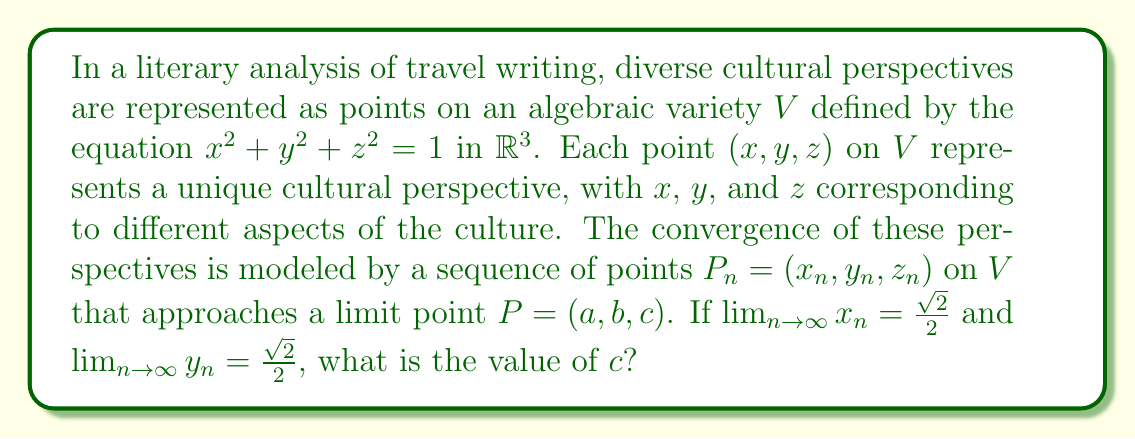Could you help me with this problem? Let's approach this step-by-step:

1) The algebraic variety $V$ is defined by the equation $x^2 + y^2 + z^2 = 1$. This is the equation of a unit sphere in $\mathbb{R}^3$.

2) We're told that the sequence of points $P_n = (x_n, y_n, z_n)$ converges to a limit point $P = (a, b, c)$ on $V$.

3) We're given that:
   $\lim_{n \to \infty} x_n = a = \frac{\sqrt{2}}{2}$
   $\lim_{n \to \infty} y_n = b = \frac{\sqrt{2}}{2}$

4) Since the limit point $P = (a, b, c)$ is on $V$, it must satisfy the equation of the sphere:

   $a^2 + b^2 + c^2 = 1$

5) Substituting the known values:

   $(\frac{\sqrt{2}}{2})^2 + (\frac{\sqrt{2}}{2})^2 + c^2 = 1$

6) Simplify:
   $\frac{2}{4} + \frac{2}{4} + c^2 = 1$
   $\frac{1}{2} + \frac{1}{2} + c^2 = 1$
   $1 + c^2 = 1$

7) Solve for $c$:
   $c^2 = 0$
   $c = 0$

Therefore, the value of $c$ is 0.
Answer: $c = 0$ 